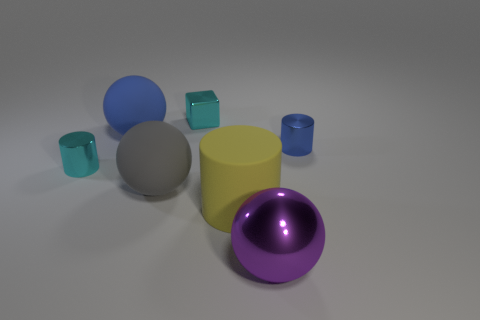Subtract all large yellow cylinders. How many cylinders are left? 2 Subtract 1 cylinders. How many cylinders are left? 2 Add 2 tiny green rubber things. How many objects exist? 9 Subtract all spheres. How many objects are left? 4 Subtract all big purple balls. Subtract all large yellow rubber objects. How many objects are left? 5 Add 1 yellow cylinders. How many yellow cylinders are left? 2 Add 2 shiny things. How many shiny things exist? 6 Subtract 0 cyan balls. How many objects are left? 7 Subtract all brown spheres. Subtract all green blocks. How many spheres are left? 3 